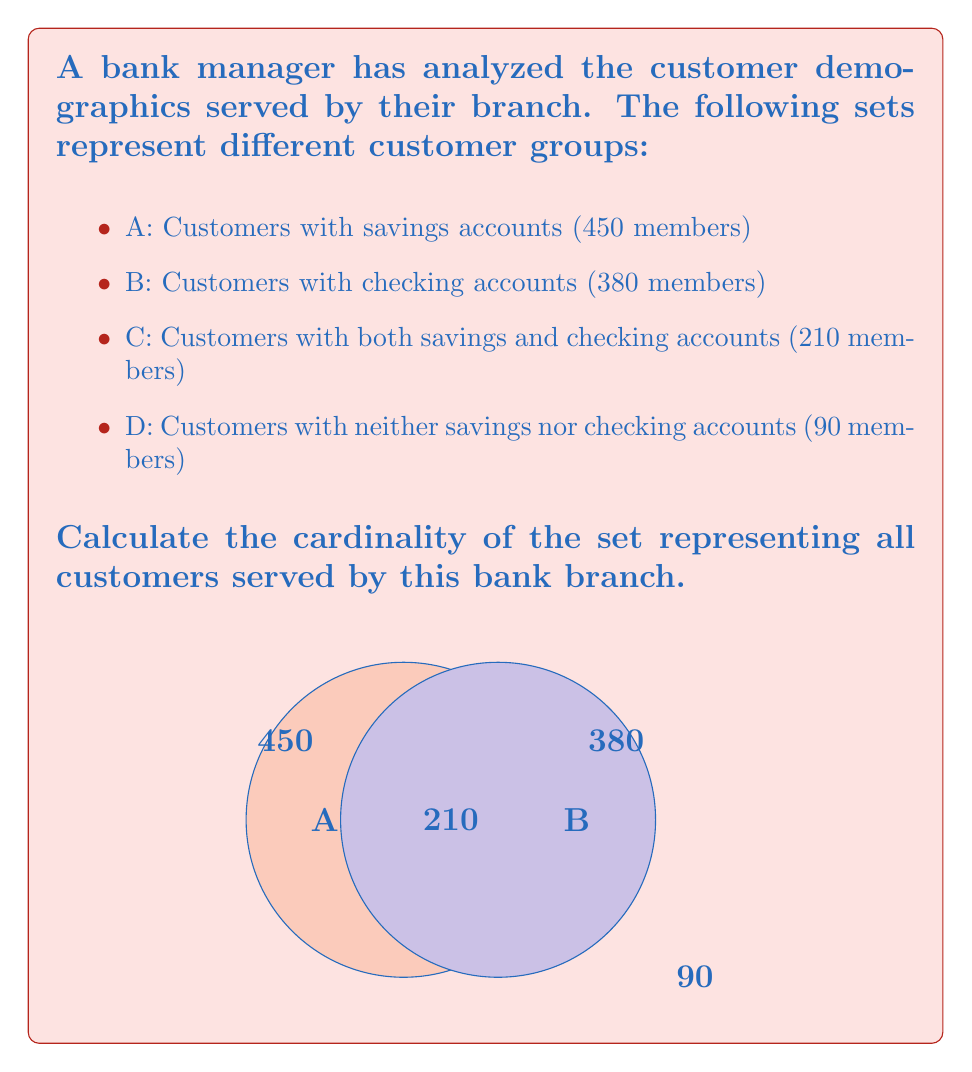Help me with this question. To solve this problem, we'll use the principle of inclusion-exclusion for two sets:

1) Let's define the universal set U as all customers served by the bank branch.

2) We know:
   $|A| = 450$ (customers with savings accounts)
   $|B| = 380$ (customers with checking accounts)
   $|A \cap B| = 210$ (customers with both types of accounts)
   $|U - (A \cup B)| = 90$ (customers with neither type of account)

3) We need to find $|U|$, which is equal to $|A \cup B| + |U - (A \cup B)|$

4) Using the inclusion-exclusion principle:
   $|A \cup B| = |A| + |B| - |A \cap B|$

5) Substituting the values:
   $|A \cup B| = 450 + 380 - 210 = 620$

6) Now, we can calculate $|U|$:
   $|U| = |A \cup B| + |U - (A \cup B)|$
   $|U| = 620 + 90 = 710$

Therefore, the bank branch serves a total of 710 customers.
Answer: 710 